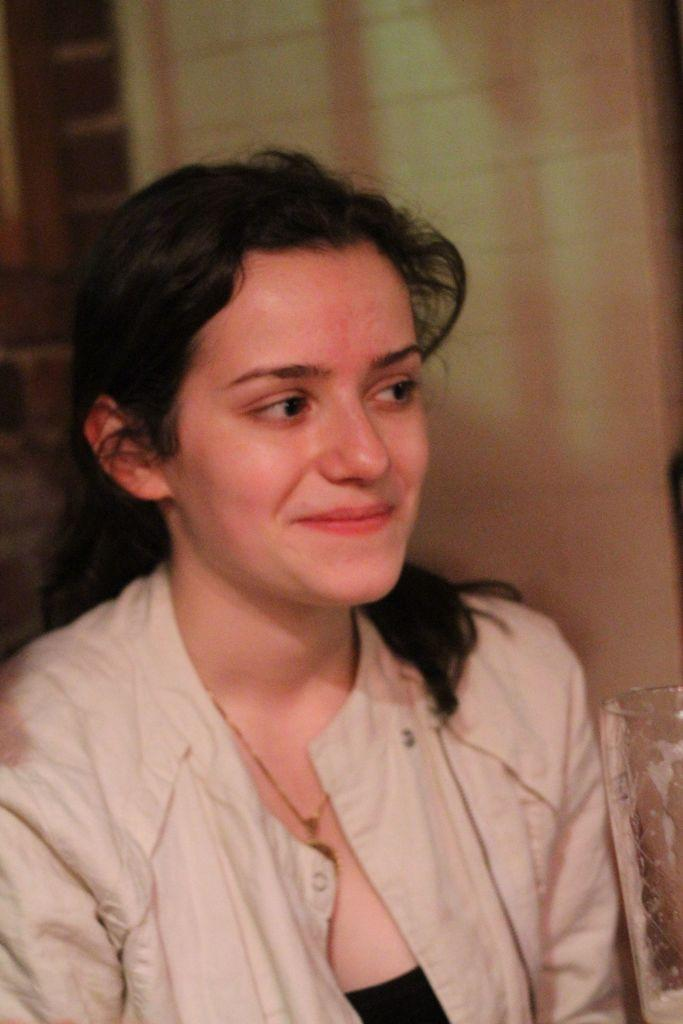Who is present in the image? There is a woman in the image. What is the woman wearing? The woman is wearing a jacket. What expression does the woman have? The woman is smiling. What can be seen in the background of the image? There is a wall in the background of the image. What type of plough is the woman using in the image? There is no plough present in the image; it features a woman wearing a jacket and smiling. 